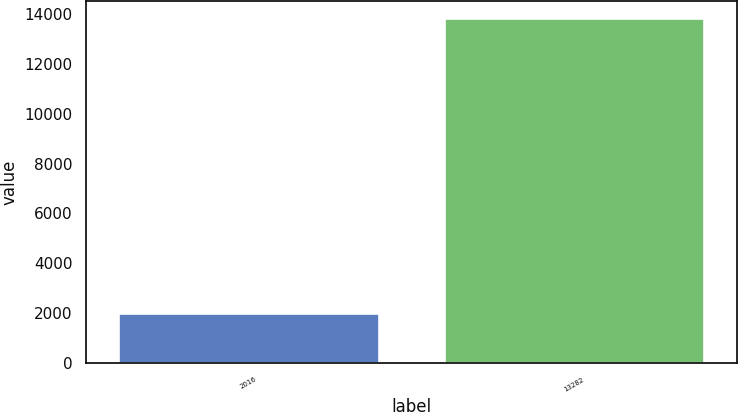Convert chart. <chart><loc_0><loc_0><loc_500><loc_500><bar_chart><fcel>2016<fcel>13282<nl><fcel>2014<fcel>13841<nl></chart> 